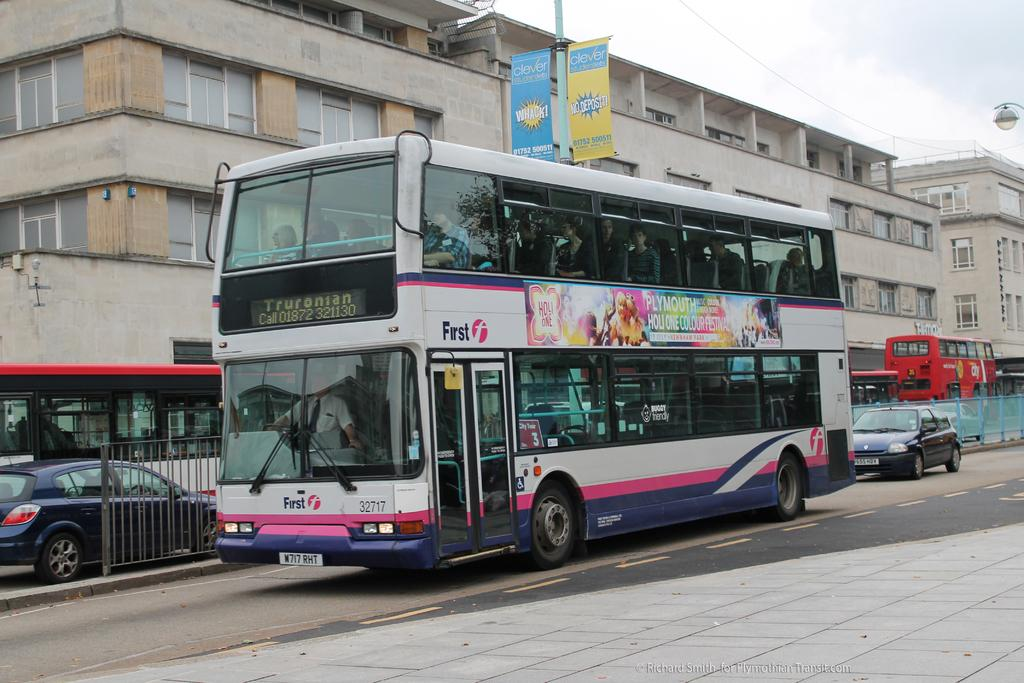<image>
Share a concise interpretation of the image provided. A double decker bus with the Plymouth Holi One Colour Festival advertsided on its' side drives down the road. 